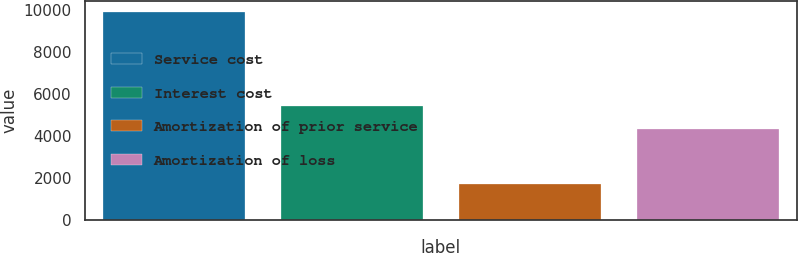Convert chart. <chart><loc_0><loc_0><loc_500><loc_500><bar_chart><fcel>Service cost<fcel>Interest cost<fcel>Amortization of prior service<fcel>Amortization of loss<nl><fcel>9944<fcel>5435<fcel>1697<fcel>4323<nl></chart> 